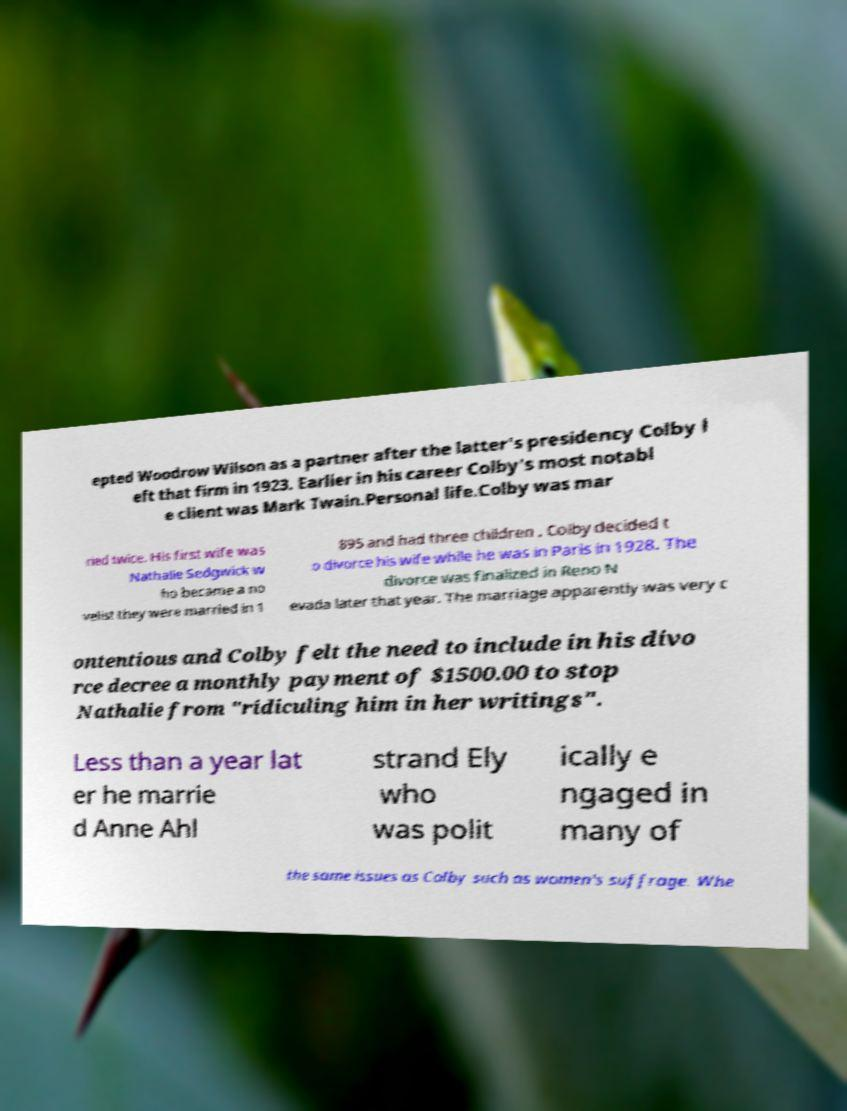Can you read and provide the text displayed in the image?This photo seems to have some interesting text. Can you extract and type it out for me? epted Woodrow Wilson as a partner after the latter's presidency Colby l eft that firm in 1923. Earlier in his career Colby's most notabl e client was Mark Twain.Personal life.Colby was mar ried twice. His first wife was Nathalie Sedgwick w ho became a no velist they were married in 1 895 and had three children . Colby decided t o divorce his wife while he was in Paris in 1928. The divorce was finalized in Reno N evada later that year. The marriage apparently was very c ontentious and Colby felt the need to include in his divo rce decree a monthly payment of $1500.00 to stop Nathalie from "ridiculing him in her writings". Less than a year lat er he marrie d Anne Ahl strand Ely who was polit ically e ngaged in many of the same issues as Colby such as women's suffrage. Whe 